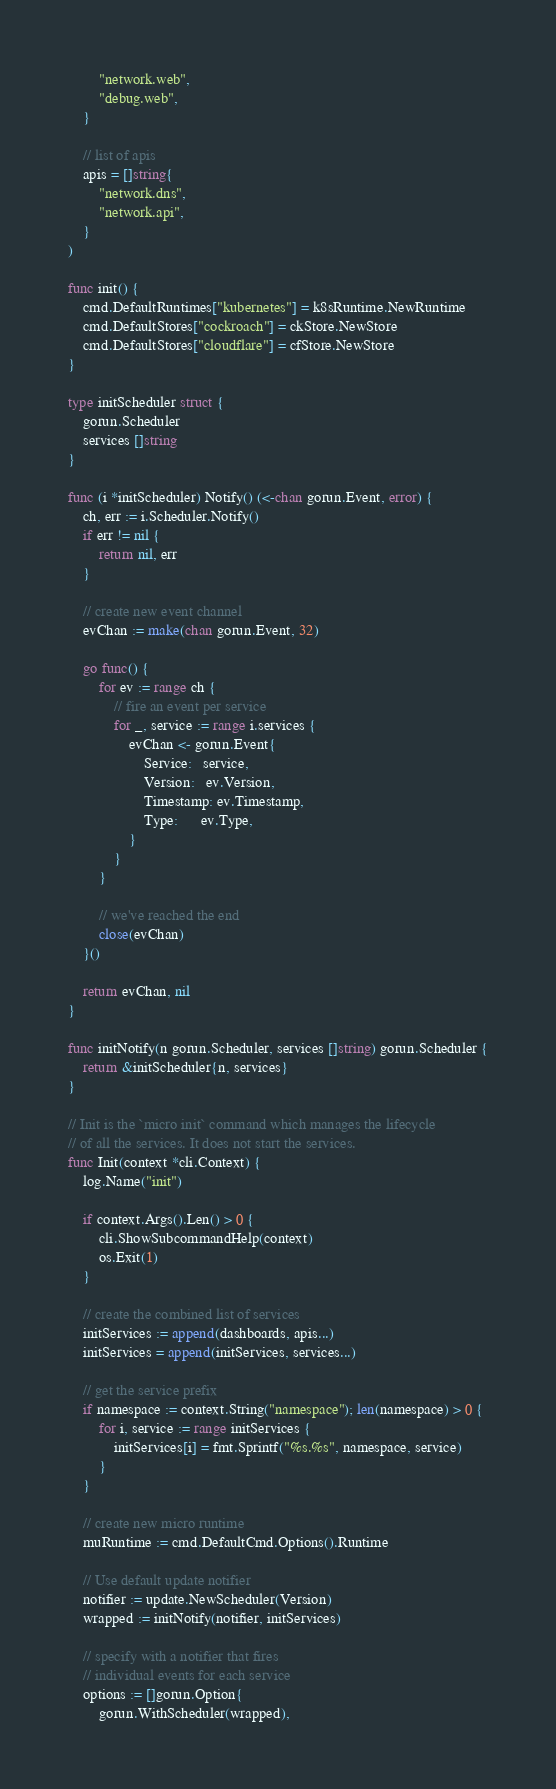<code> <loc_0><loc_0><loc_500><loc_500><_Go_>		"network.web",
		"debug.web",
	}

	// list of apis
	apis = []string{
		"network.dns",
		"network.api",
	}
)

func init() {
	cmd.DefaultRuntimes["kubernetes"] = k8sRuntime.NewRuntime
	cmd.DefaultStores["cockroach"] = ckStore.NewStore
	cmd.DefaultStores["cloudflare"] = cfStore.NewStore
}

type initScheduler struct {
	gorun.Scheduler
	services []string
}

func (i *initScheduler) Notify() (<-chan gorun.Event, error) {
	ch, err := i.Scheduler.Notify()
	if err != nil {
		return nil, err
	}

	// create new event channel
	evChan := make(chan gorun.Event, 32)

	go func() {
		for ev := range ch {
			// fire an event per service
			for _, service := range i.services {
				evChan <- gorun.Event{
					Service:   service,
					Version:   ev.Version,
					Timestamp: ev.Timestamp,
					Type:      ev.Type,
				}
			}
		}

		// we've reached the end
		close(evChan)
	}()

	return evChan, nil
}

func initNotify(n gorun.Scheduler, services []string) gorun.Scheduler {
	return &initScheduler{n, services}
}

// Init is the `micro init` command which manages the lifecycle
// of all the services. It does not start the services.
func Init(context *cli.Context) {
	log.Name("init")

	if context.Args().Len() > 0 {
		cli.ShowSubcommandHelp(context)
		os.Exit(1)
	}

	// create the combined list of services
	initServices := append(dashboards, apis...)
	initServices = append(initServices, services...)

	// get the service prefix
	if namespace := context.String("namespace"); len(namespace) > 0 {
		for i, service := range initServices {
			initServices[i] = fmt.Sprintf("%s.%s", namespace, service)
		}
	}

	// create new micro runtime
	muRuntime := cmd.DefaultCmd.Options().Runtime

	// Use default update notifier
	notifier := update.NewScheduler(Version)
	wrapped := initNotify(notifier, initServices)

	// specify with a notifier that fires
	// individual events for each service
	options := []gorun.Option{
		gorun.WithScheduler(wrapped),</code> 